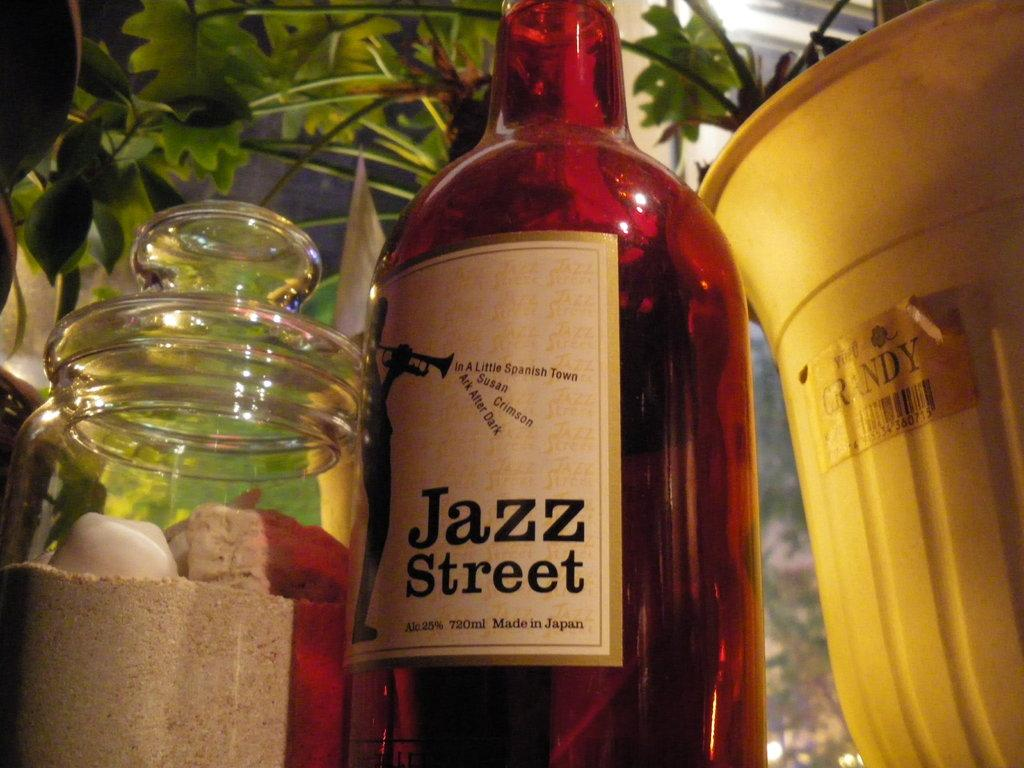<image>
Share a concise interpretation of the image provided. A bottle of red liquid that reads Jazz Street. 